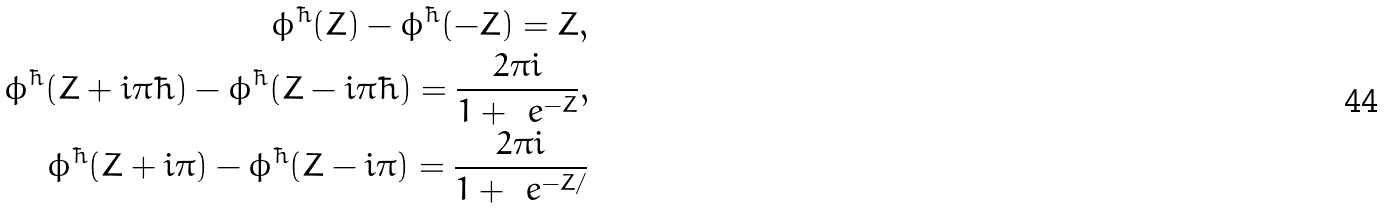<formula> <loc_0><loc_0><loc_500><loc_500>\phi ^ { \hbar } ( Z ) - \phi ^ { \hbar } ( - Z ) = Z , \\ \phi ^ { \hbar } ( Z + i \pi \hbar { ) } - \phi ^ { \hbar } ( Z - i \pi \hbar { ) } = \frac { 2 \pi i } { 1 + \ e ^ { - Z } } , \\ \phi ^ { \hbar } ( Z + i \pi ) - \phi ^ { \hbar } ( Z - i \pi ) = \frac { 2 \pi i } { 1 + \ e ^ { - Z / } }</formula> 